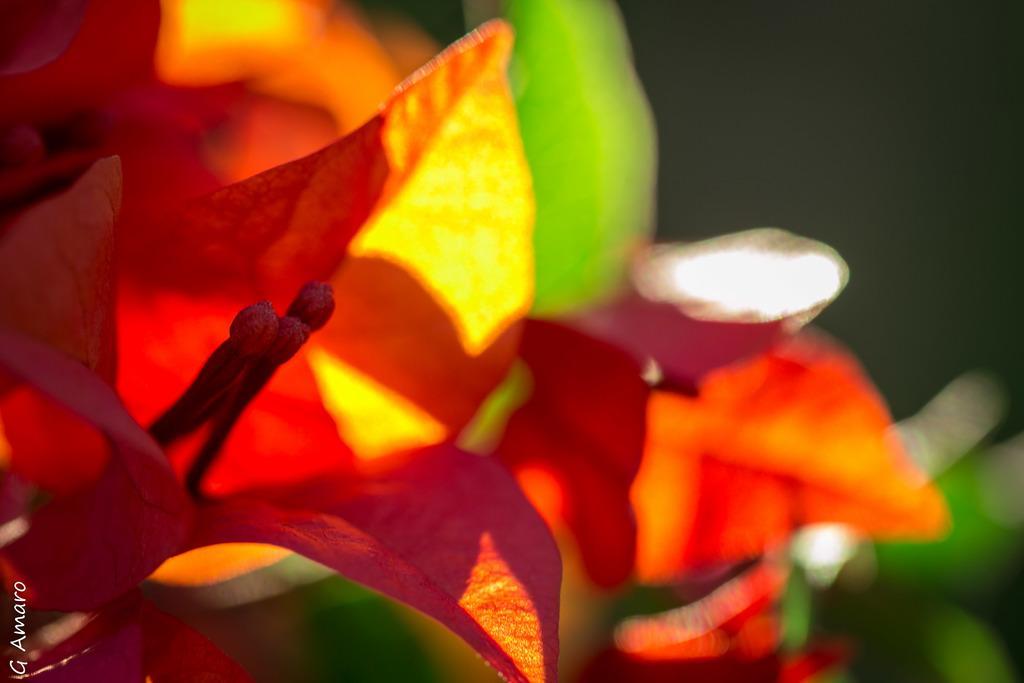Could you give a brief overview of what you see in this image? In this picture I can see leaves and I can see text at the bottom left corner of the picture. 